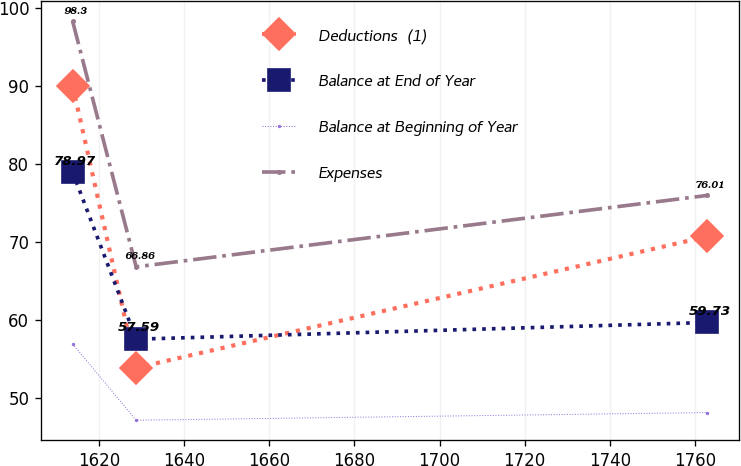Convert chart to OTSL. <chart><loc_0><loc_0><loc_500><loc_500><line_chart><ecel><fcel>Deductions  (1)<fcel>Balance at End of Year<fcel>Balance at Beginning of Year<fcel>Expenses<nl><fcel>1613.87<fcel>90.02<fcel>78.97<fcel>56.97<fcel>98.3<nl><fcel>1628.77<fcel>53.92<fcel>57.59<fcel>47.21<fcel>66.86<nl><fcel>1762.89<fcel>70.75<fcel>59.73<fcel>48.19<fcel>76.01<nl></chart> 